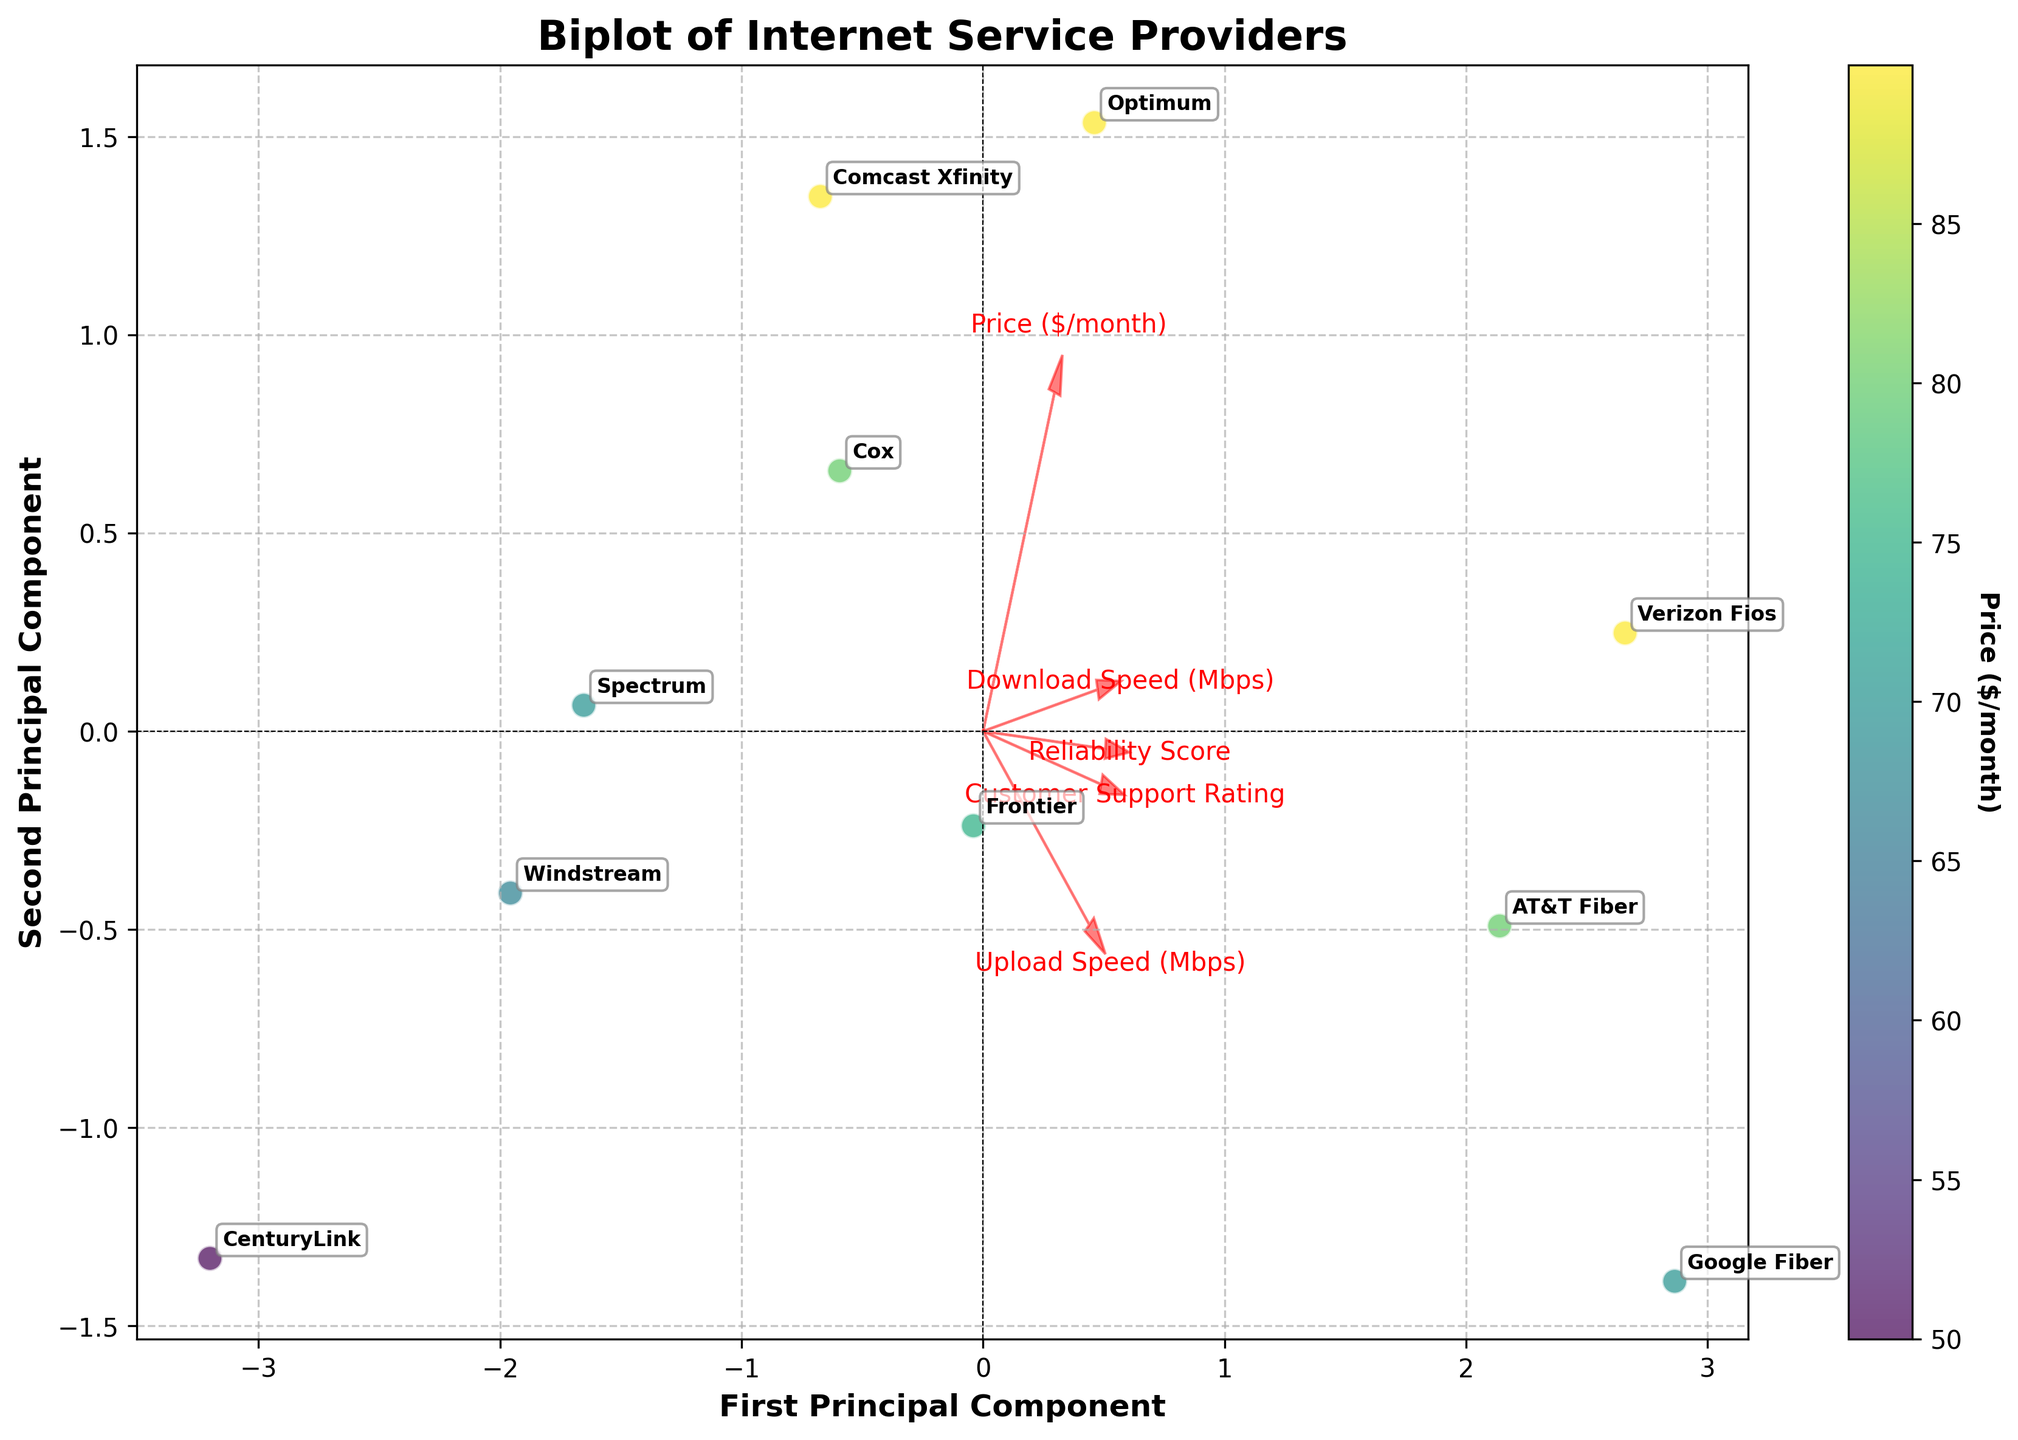How many service providers are shown in the biplot? The number of data points in the plot corresponds to the number of service providers. By counting the annotations or data points on the biplot, we can determine the number of service providers shown.
Answer: 10 What does the color of the data points represent in the biplot? The color of the data points is explained by referring to the colorbar on the right side of the biplot. The label on the colorbar indicates that it represents the price per month.
Answer: Price per month Which service provider has the highest reliability score? To determine this, we look at the arrows representing the features, particularly the 'Reliability Score' vector. The provider closest and in the direction of this vector would have the highest reliability score.
Answer: Google Fiber Which two features are the most strongly correlated with the first principal component? We need to observe the direction and length of the arrows from the origin. The features with arrows pointing most directly along the x-axis (first principal component) and the longest arrows indicate strong correlation.
Answer: Download Speed (Mbps) and Upload Speed (Mbps) Which provider appears to be the most expensive? By examining the color of each data point and comparing it to the colorbar, we identify the data point with the deepest shade indicating the highest price.
Answer: Comcast Xfinity, Verizon Fios, Optimum Are there any service providers that offer both a high download speed and a high reliability score? We look for data points positioned in the direction where both 'Download Speed (Mbps)' and 'Reliability Score' arrows lie, and at a considerable distance indicating higher values for these features.
Answer: AT&T Fiber, Verizon Fios, Google Fiber What is the overall trend between customer support rating and price? Evaluating the positioning of the 'Customer Support Rating' and 'Price ($/month)' vectors in relation to each other gives an idea of their trend. Parallel vectors suggest proportional trend, opposite directions indicate inverse trend, etc.
Answer: Slightly positive trend Which service provider offers the best customer support? By observing the positioning in relation to the 'Customer Support Rating' vector, the data point closest and directionally aligned with this vector suggests the highest rating.
Answer: Google Fiber Which two service providers are the nearest to each other in terms of principal component space? By comparing the placements of the data points in the biplot, the two closest points in both x and y directions are identified.
Answer: AT&T Fiber and Google Fiber 